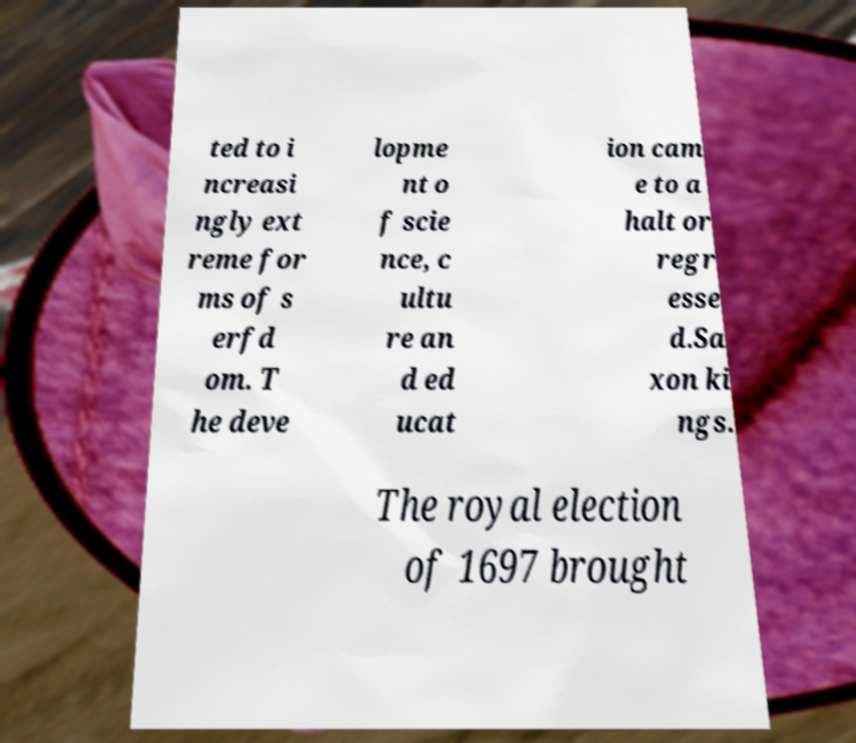Please identify and transcribe the text found in this image. ted to i ncreasi ngly ext reme for ms of s erfd om. T he deve lopme nt o f scie nce, c ultu re an d ed ucat ion cam e to a halt or regr esse d.Sa xon ki ngs. The royal election of 1697 brought 